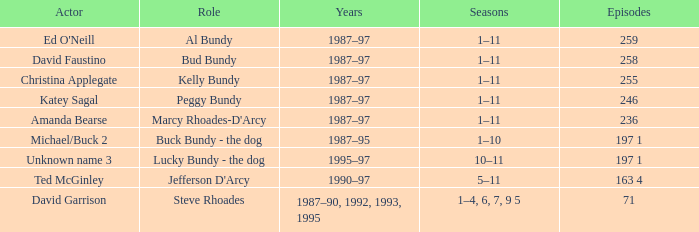How many episodes did the actor David Faustino appear in? 258.0. Would you mind parsing the complete table? {'header': ['Actor', 'Role', 'Years', 'Seasons', 'Episodes'], 'rows': [["Ed O'Neill", 'Al Bundy', '1987–97', '1–11', '259'], ['David Faustino', 'Bud Bundy', '1987–97', '1–11', '258'], ['Christina Applegate', 'Kelly Bundy', '1987–97', '1–11', '255'], ['Katey Sagal', 'Peggy Bundy', '1987–97', '1–11', '246'], ['Amanda Bearse', "Marcy Rhoades-D'Arcy", '1987–97', '1–11', '236'], ['Michael/Buck 2', 'Buck Bundy - the dog', '1987–95', '1–10', '197 1'], ['Unknown name 3', 'Lucky Bundy - the dog', '1995–97', '10–11', '197 1'], ['Ted McGinley', "Jefferson D'Arcy", '1990–97', '5–11', '163 4'], ['David Garrison', 'Steve Rhoades', '1987–90, 1992, 1993, 1995', '1–4, 6, 7, 9 5', '71']]} 